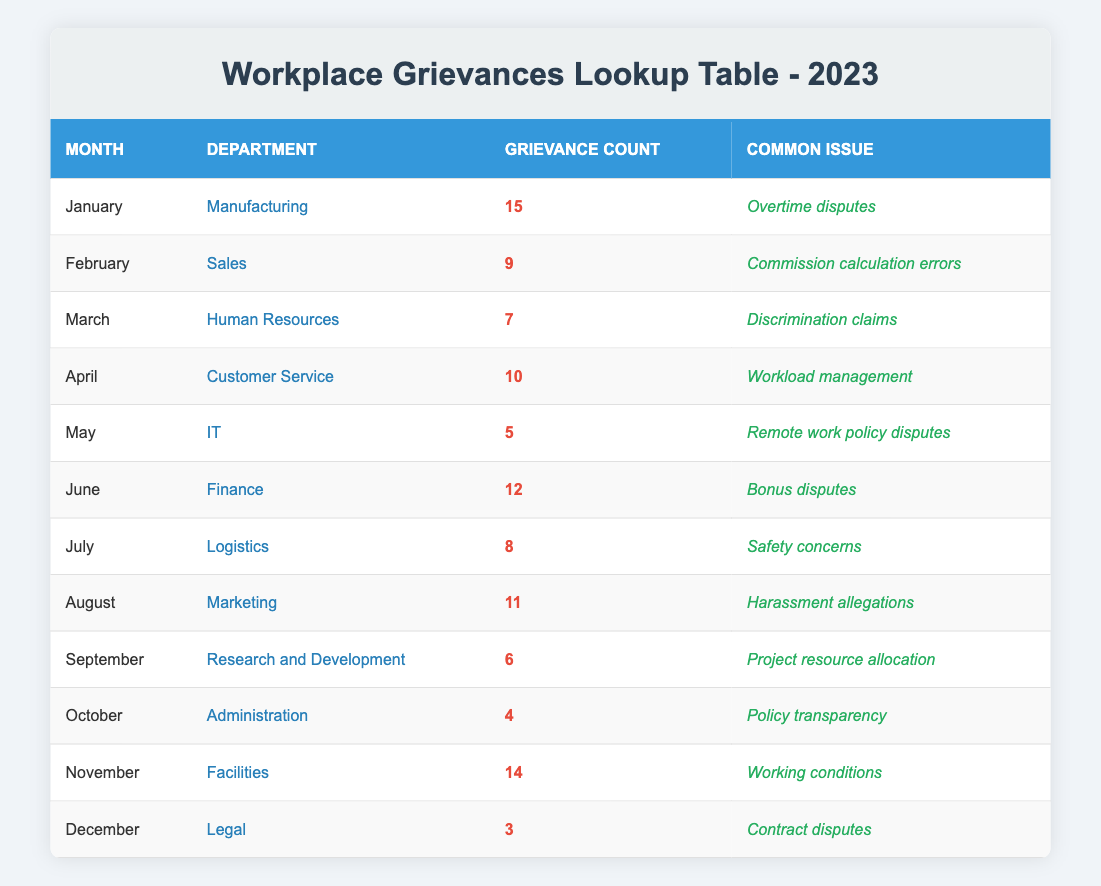What was the grievance count for the Human Resources department in March? The table shows that the grievance count for the Human Resources department in March is listed directly under the grievance count column for that month.
Answer: 7 Which month had the highest number of grievances reported? By examining the grievance count for each month, January has the highest count with 15 grievances reported.
Answer: January What is the total number of grievances reported from January to June? We need to sum the grievance counts from January to June: (15 + 9 + 7 + 10 + 5 + 12) = 58.
Answer: 58 Did the IT department have more grievances than the Marketing department in August? IT reported 5 grievances, while Marketing reported 11 grievances. Since 5 is less than 11, it is true that IT had fewer grievances than Marketing.
Answer: No What was the common issue reported most frequently in the table? Observing the issues listed, there is no explicit frequency count. However, looking at the context, we see that the issues are unique to each month. Thus, we cannot determine which issue was reported most frequently directly from the table.
Answer: N/A What was the average number of grievances per month for the second half of the year (July to December)? We first sum the grievances from July to December: (8 + 11 + 6 + 4 + 14 + 3) = 46. Then, we divide by the number of months, which is 6, giving us an average of 46/6 ≈ 7.67.
Answer: 8 In which department was "Workload management" the most common issue, and how many grievances were reported? "Workload management" is listed under Customer Service for April with a grievance count of 10, which indicates the department and grievance count.
Answer: Customer Service, 10 Was there a month in which fewer than 5 grievances were reported? Checking the grievance counts, October had 4 grievances and December had 3 grievances, meaning both months had fewer than 5 grievances reported.
Answer: Yes Which department had the least number of grievances reported in December? The table indicates that the Legal department reported 3 grievances, which is the lowest count shown for December.
Answer: Legal, 3 